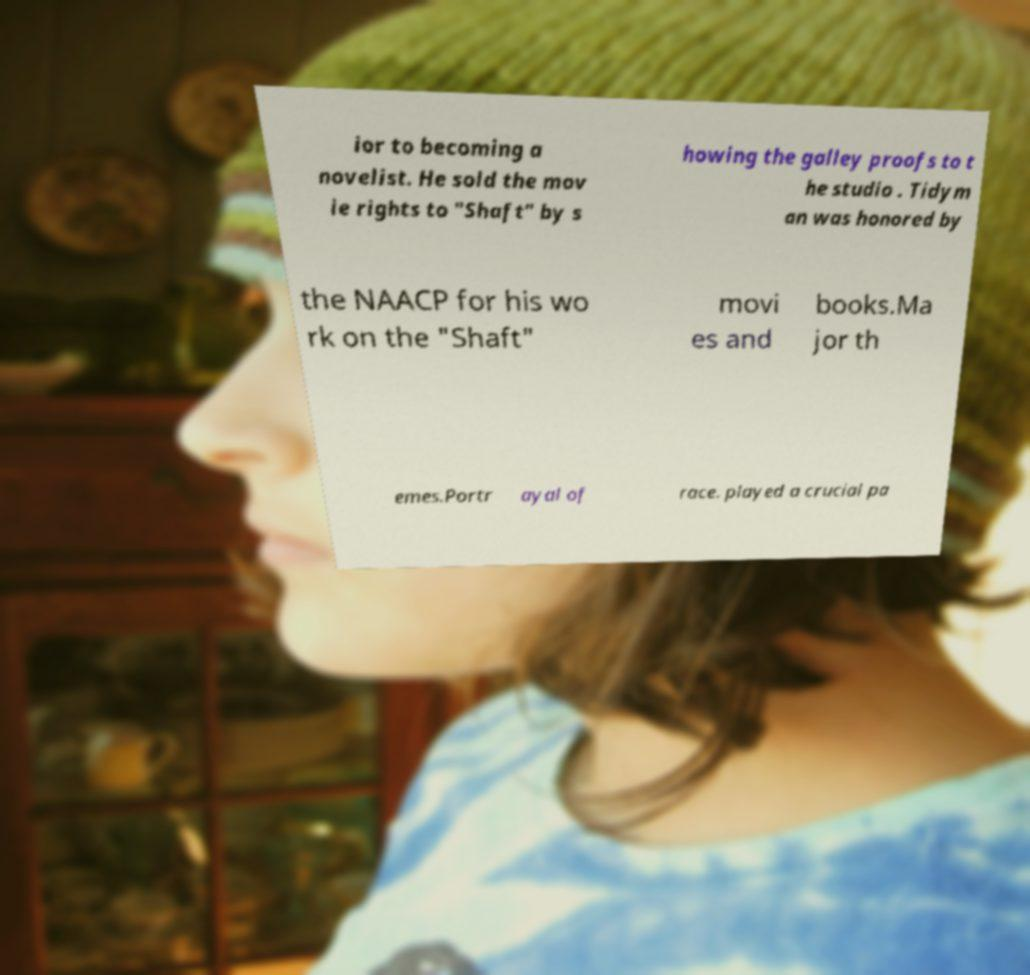Please read and relay the text visible in this image. What does it say? ior to becoming a novelist. He sold the mov ie rights to "Shaft" by s howing the galley proofs to t he studio . Tidym an was honored by the NAACP for his wo rk on the "Shaft" movi es and books.Ma jor th emes.Portr ayal of race. played a crucial pa 